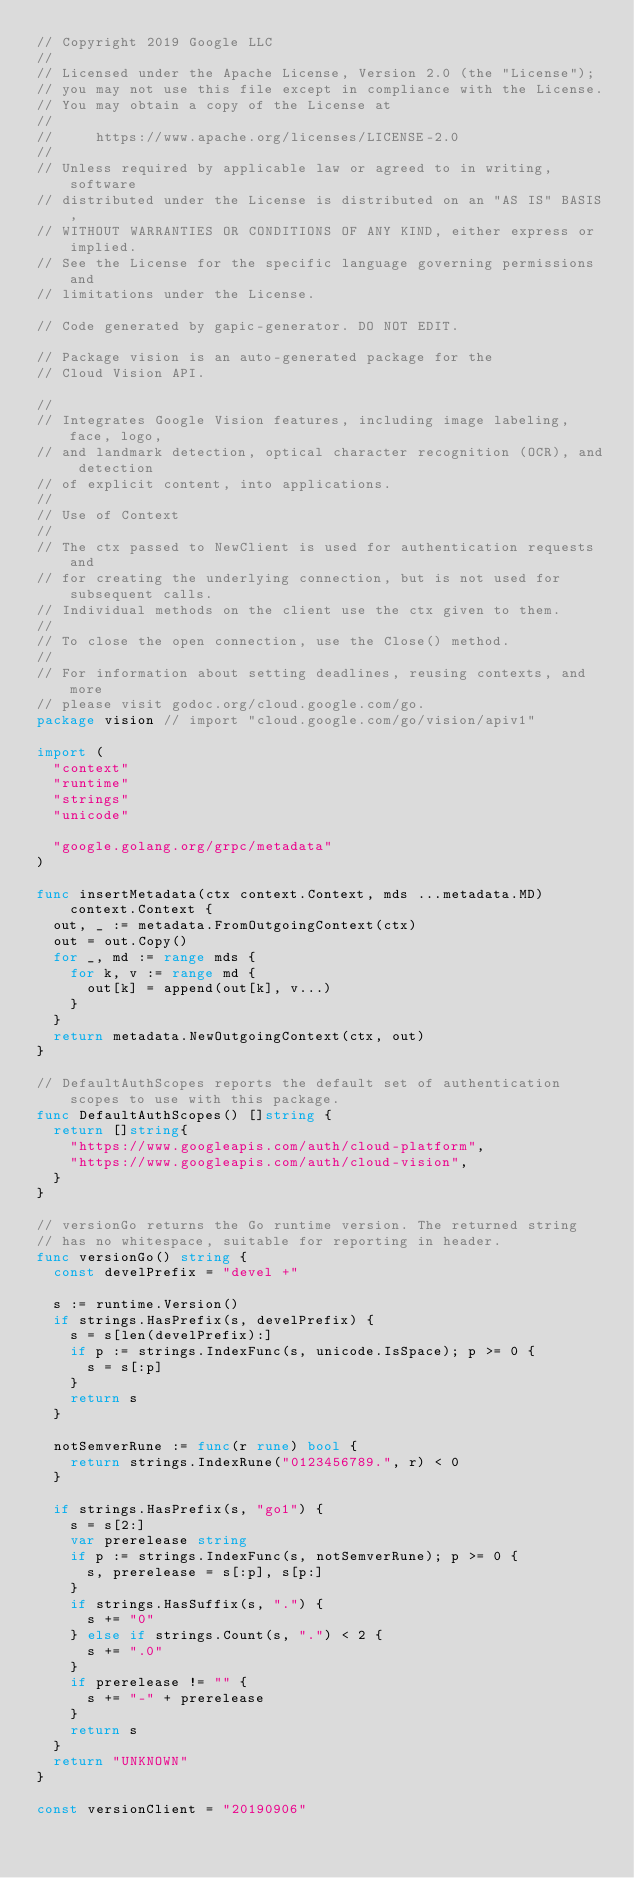Convert code to text. <code><loc_0><loc_0><loc_500><loc_500><_Go_>// Copyright 2019 Google LLC
//
// Licensed under the Apache License, Version 2.0 (the "License");
// you may not use this file except in compliance with the License.
// You may obtain a copy of the License at
//
//     https://www.apache.org/licenses/LICENSE-2.0
//
// Unless required by applicable law or agreed to in writing, software
// distributed under the License is distributed on an "AS IS" BASIS,
// WITHOUT WARRANTIES OR CONDITIONS OF ANY KIND, either express or implied.
// See the License for the specific language governing permissions and
// limitations under the License.

// Code generated by gapic-generator. DO NOT EDIT.

// Package vision is an auto-generated package for the
// Cloud Vision API.

//
// Integrates Google Vision features, including image labeling, face, logo,
// and landmark detection, optical character recognition (OCR), and detection
// of explicit content, into applications.
//
// Use of Context
//
// The ctx passed to NewClient is used for authentication requests and
// for creating the underlying connection, but is not used for subsequent calls.
// Individual methods on the client use the ctx given to them.
//
// To close the open connection, use the Close() method.
//
// For information about setting deadlines, reusing contexts, and more
// please visit godoc.org/cloud.google.com/go.
package vision // import "cloud.google.com/go/vision/apiv1"

import (
	"context"
	"runtime"
	"strings"
	"unicode"

	"google.golang.org/grpc/metadata"
)

func insertMetadata(ctx context.Context, mds ...metadata.MD) context.Context {
	out, _ := metadata.FromOutgoingContext(ctx)
	out = out.Copy()
	for _, md := range mds {
		for k, v := range md {
			out[k] = append(out[k], v...)
		}
	}
	return metadata.NewOutgoingContext(ctx, out)
}

// DefaultAuthScopes reports the default set of authentication scopes to use with this package.
func DefaultAuthScopes() []string {
	return []string{
		"https://www.googleapis.com/auth/cloud-platform",
		"https://www.googleapis.com/auth/cloud-vision",
	}
}

// versionGo returns the Go runtime version. The returned string
// has no whitespace, suitable for reporting in header.
func versionGo() string {
	const develPrefix = "devel +"

	s := runtime.Version()
	if strings.HasPrefix(s, develPrefix) {
		s = s[len(develPrefix):]
		if p := strings.IndexFunc(s, unicode.IsSpace); p >= 0 {
			s = s[:p]
		}
		return s
	}

	notSemverRune := func(r rune) bool {
		return strings.IndexRune("0123456789.", r) < 0
	}

	if strings.HasPrefix(s, "go1") {
		s = s[2:]
		var prerelease string
		if p := strings.IndexFunc(s, notSemverRune); p >= 0 {
			s, prerelease = s[:p], s[p:]
		}
		if strings.HasSuffix(s, ".") {
			s += "0"
		} else if strings.Count(s, ".") < 2 {
			s += ".0"
		}
		if prerelease != "" {
			s += "-" + prerelease
		}
		return s
	}
	return "UNKNOWN"
}

const versionClient = "20190906"
</code> 